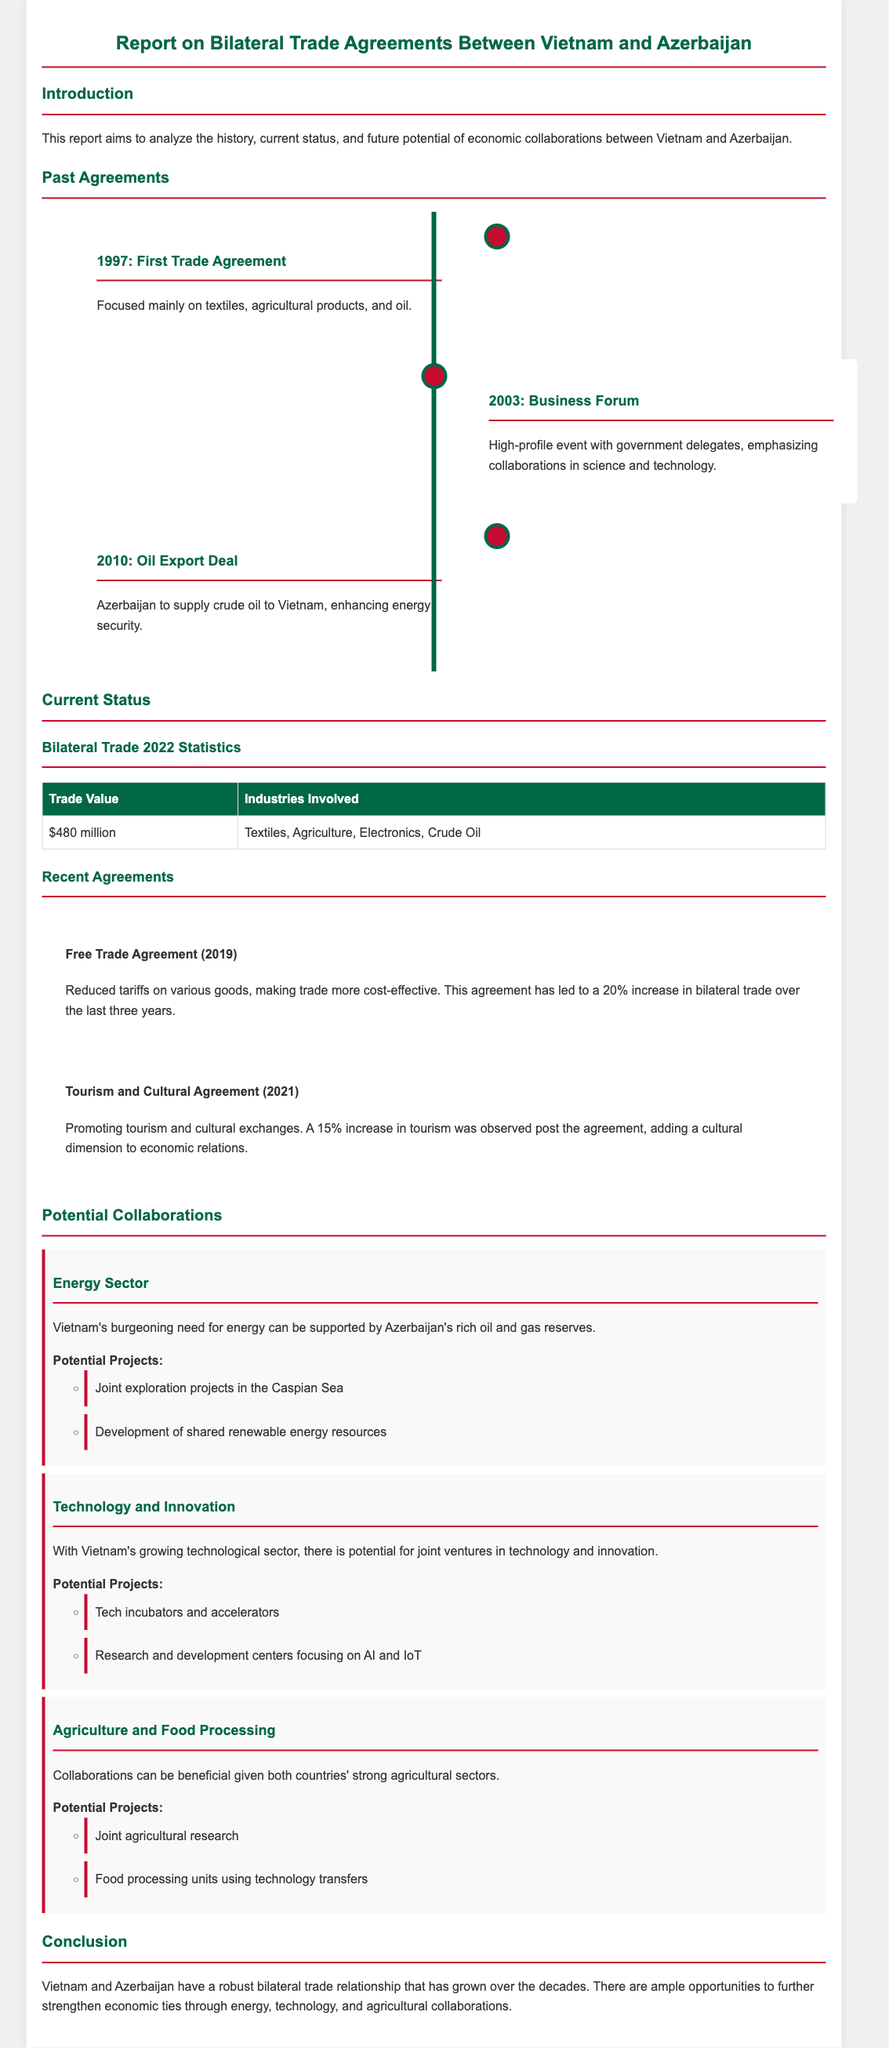What year was the first trade agreement signed? The document states the first trade agreement between Vietnam and Azerbaijan was in 1997.
Answer: 1997 What was one focus of the 1997 agreement? The document indicates that the first trade agreement primarily focused on textiles, agricultural products, and oil.
Answer: Textiles What was the trade value in 2022? According to the statistics provided in the document, the trade value between Vietnam and Azerbaijan in 2022 was $480 million.
Answer: $480 million How much did bilateral trade increase after the free trade agreement in 2019? The report mentions a 20% increase in bilateral trade over the last three years after this agreement.
Answer: 20% What are two sectors mentioned for potential collaboration? The document lists the energy sector and technology and innovation as areas for potential collaborations between the countries.
Answer: Energy, Technology Which agreement was signed in 2021? The document specifies that a Tourism and Cultural Agreement was signed in 2021 to promote tourism and cultural exchanges.
Answer: Tourism and Cultural Agreement What significant deal was made in 2010? The document highlights that in 2010, an oil export deal was established for Azerbaijan to supply crude oil to Vietnam.
Answer: Oil Export Deal What type of educational partnerships are suggested? The potential collaborations section mentions establishing tech incubators and accelerators as a suggested project in the technology sector.
Answer: Tech incubators What is a potential agricultural project mentioned? The report states that joint agricultural research is a potential project in the agriculture and food processing sector.
Answer: Joint agricultural research 